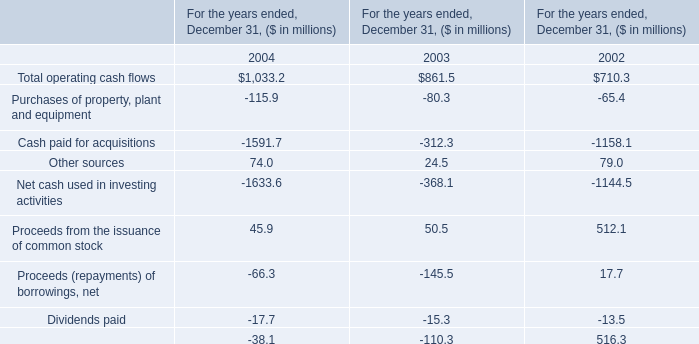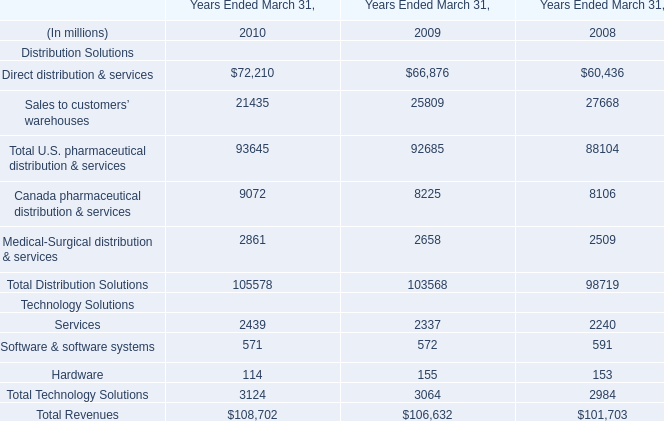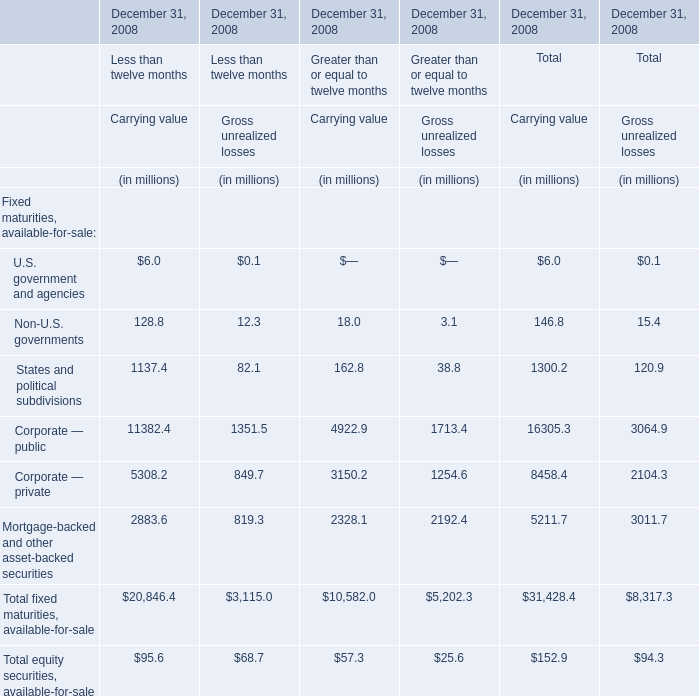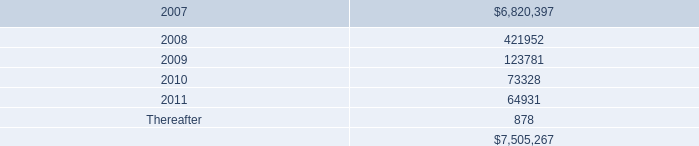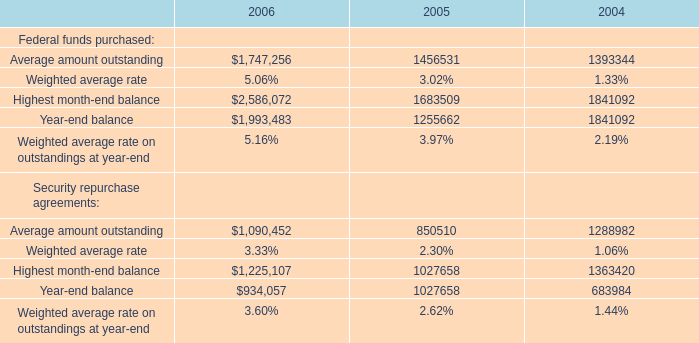What is the percentage of all Carrying value that are positive to the total amount, in 2008 for Greater than or equal to twelve months? 
Computations: ((((((18.0 + 162.8) + 4922.9) + 3150.2) + 2328.1) + 57.3) / (10582.0 + 57.3))
Answer: 1.0. 